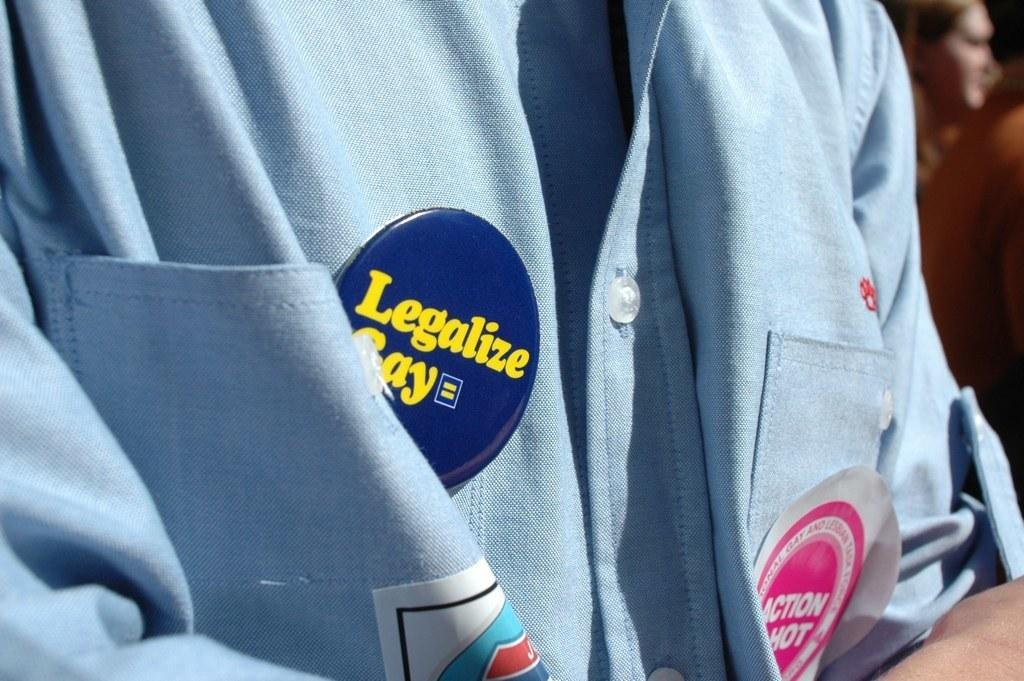<image>
Write a terse but informative summary of the picture. A person wearing a blue shirt has a button on it that says Legalize Gay. 